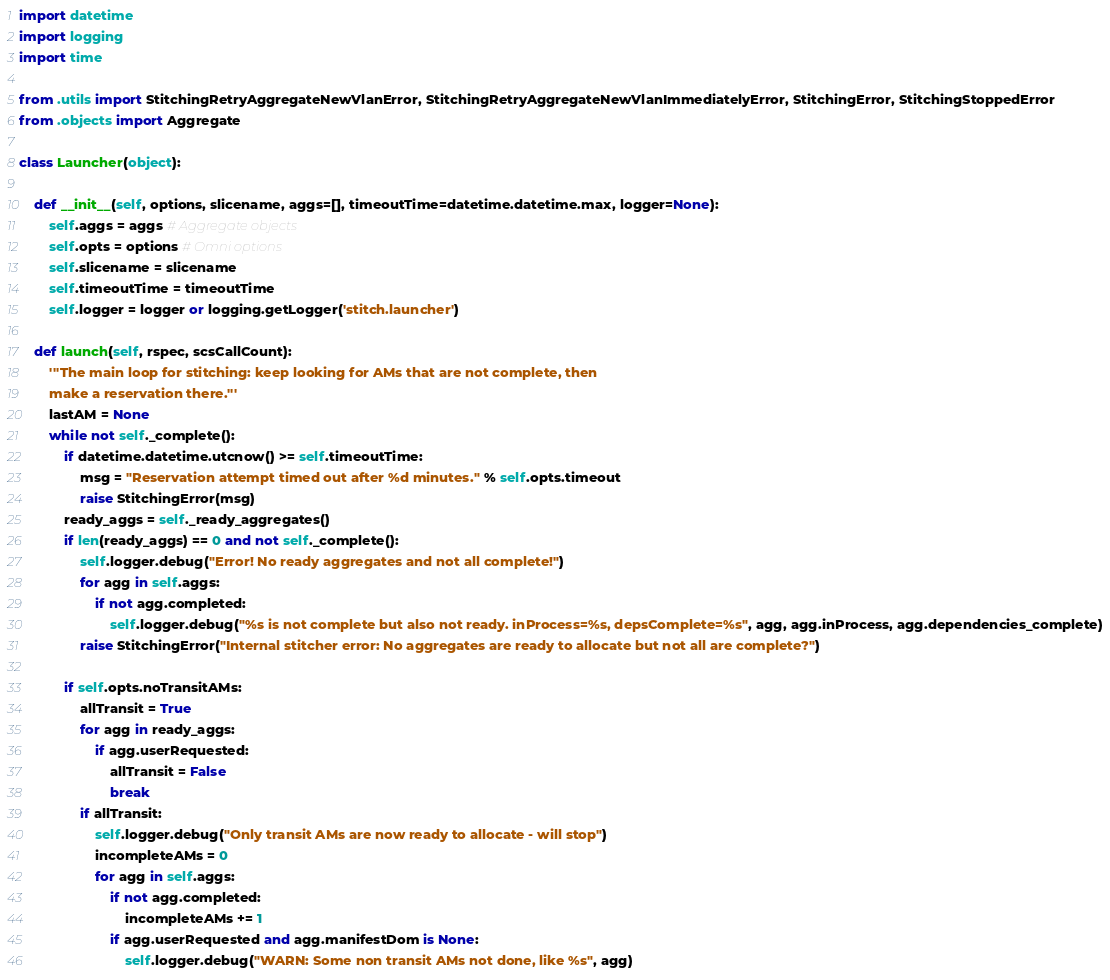Convert code to text. <code><loc_0><loc_0><loc_500><loc_500><_Python_>
import datetime
import logging
import time

from .utils import StitchingRetryAggregateNewVlanError, StitchingRetryAggregateNewVlanImmediatelyError, StitchingError, StitchingStoppedError
from .objects import Aggregate

class Launcher(object):

    def __init__(self, options, slicename, aggs=[], timeoutTime=datetime.datetime.max, logger=None):
        self.aggs = aggs # Aggregate objects
        self.opts = options # Omni options
        self.slicename = slicename
        self.timeoutTime = timeoutTime
        self.logger = logger or logging.getLogger('stitch.launcher')

    def launch(self, rspec, scsCallCount):
        '''The main loop for stitching: keep looking for AMs that are not complete, then 
        make a reservation there.'''
        lastAM = None
        while not self._complete():
            if datetime.datetime.utcnow() >= self.timeoutTime:
                msg = "Reservation attempt timed out after %d minutes." % self.opts.timeout
                raise StitchingError(msg)
            ready_aggs = self._ready_aggregates()
            if len(ready_aggs) == 0 and not self._complete():
                self.logger.debug("Error! No ready aggregates and not all complete!")
                for agg in self.aggs:
                    if not agg.completed:
                        self.logger.debug("%s is not complete but also not ready. inProcess=%s, depsComplete=%s", agg, agg.inProcess, agg.dependencies_complete)
                raise StitchingError("Internal stitcher error: No aggregates are ready to allocate but not all are complete?")

            if self.opts.noTransitAMs:
                allTransit = True
                for agg in ready_aggs:
                    if agg.userRequested:
                        allTransit = False
                        break
                if allTransit:
                    self.logger.debug("Only transit AMs are now ready to allocate - will stop")
                    incompleteAMs = 0
                    for agg in self.aggs:
                        if not agg.completed:
                            incompleteAMs += 1
                        if agg.userRequested and agg.manifestDom is None:
                            self.logger.debug("WARN: Some non transit AMs not done, like %s", agg)</code> 